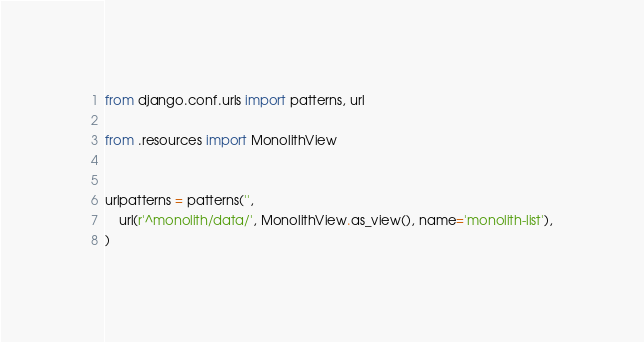<code> <loc_0><loc_0><loc_500><loc_500><_Python_>from django.conf.urls import patterns, url

from .resources import MonolithView


urlpatterns = patterns('',
    url(r'^monolith/data/', MonolithView.as_view(), name='monolith-list'),
)
</code> 